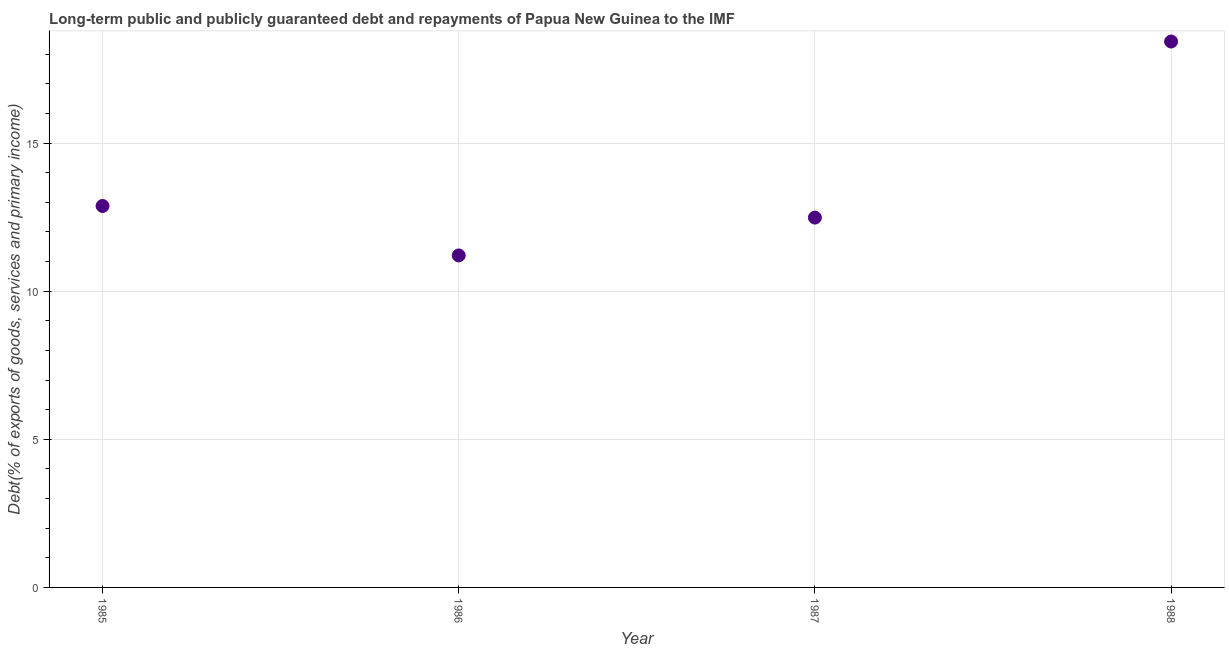What is the debt service in 1988?
Keep it short and to the point. 18.43. Across all years, what is the maximum debt service?
Make the answer very short. 18.43. Across all years, what is the minimum debt service?
Keep it short and to the point. 11.21. In which year was the debt service minimum?
Ensure brevity in your answer.  1986. What is the sum of the debt service?
Provide a succinct answer. 54.99. What is the difference between the debt service in 1985 and 1987?
Keep it short and to the point. 0.39. What is the average debt service per year?
Offer a very short reply. 13.75. What is the median debt service?
Give a very brief answer. 12.68. Do a majority of the years between 1986 and 1985 (inclusive) have debt service greater than 7 %?
Ensure brevity in your answer.  No. What is the ratio of the debt service in 1987 to that in 1988?
Provide a short and direct response. 0.68. Is the difference between the debt service in 1987 and 1988 greater than the difference between any two years?
Your answer should be compact. No. What is the difference between the highest and the second highest debt service?
Ensure brevity in your answer.  5.55. What is the difference between the highest and the lowest debt service?
Ensure brevity in your answer.  7.22. In how many years, is the debt service greater than the average debt service taken over all years?
Offer a terse response. 1. How many dotlines are there?
Make the answer very short. 1. What is the difference between two consecutive major ticks on the Y-axis?
Make the answer very short. 5. Are the values on the major ticks of Y-axis written in scientific E-notation?
Offer a very short reply. No. Does the graph contain grids?
Give a very brief answer. Yes. What is the title of the graph?
Your response must be concise. Long-term public and publicly guaranteed debt and repayments of Papua New Guinea to the IMF. What is the label or title of the X-axis?
Provide a short and direct response. Year. What is the label or title of the Y-axis?
Give a very brief answer. Debt(% of exports of goods, services and primary income). What is the Debt(% of exports of goods, services and primary income) in 1985?
Offer a terse response. 12.88. What is the Debt(% of exports of goods, services and primary income) in 1986?
Keep it short and to the point. 11.21. What is the Debt(% of exports of goods, services and primary income) in 1987?
Your answer should be compact. 12.48. What is the Debt(% of exports of goods, services and primary income) in 1988?
Give a very brief answer. 18.43. What is the difference between the Debt(% of exports of goods, services and primary income) in 1985 and 1986?
Give a very brief answer. 1.67. What is the difference between the Debt(% of exports of goods, services and primary income) in 1985 and 1987?
Offer a terse response. 0.39. What is the difference between the Debt(% of exports of goods, services and primary income) in 1985 and 1988?
Your answer should be compact. -5.55. What is the difference between the Debt(% of exports of goods, services and primary income) in 1986 and 1987?
Your answer should be very brief. -1.28. What is the difference between the Debt(% of exports of goods, services and primary income) in 1986 and 1988?
Offer a terse response. -7.22. What is the difference between the Debt(% of exports of goods, services and primary income) in 1987 and 1988?
Provide a short and direct response. -5.94. What is the ratio of the Debt(% of exports of goods, services and primary income) in 1985 to that in 1986?
Provide a short and direct response. 1.15. What is the ratio of the Debt(% of exports of goods, services and primary income) in 1985 to that in 1987?
Your answer should be very brief. 1.03. What is the ratio of the Debt(% of exports of goods, services and primary income) in 1985 to that in 1988?
Keep it short and to the point. 0.7. What is the ratio of the Debt(% of exports of goods, services and primary income) in 1986 to that in 1987?
Offer a very short reply. 0.9. What is the ratio of the Debt(% of exports of goods, services and primary income) in 1986 to that in 1988?
Offer a very short reply. 0.61. What is the ratio of the Debt(% of exports of goods, services and primary income) in 1987 to that in 1988?
Keep it short and to the point. 0.68. 